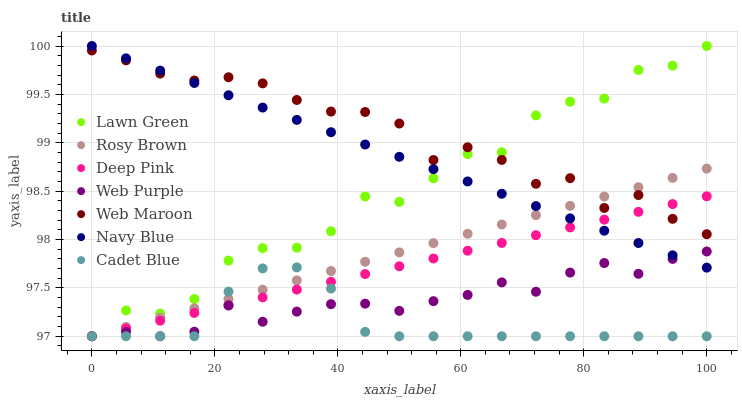Does Cadet Blue have the minimum area under the curve?
Answer yes or no. Yes. Does Web Maroon have the maximum area under the curve?
Answer yes or no. Yes. Does Deep Pink have the minimum area under the curve?
Answer yes or no. No. Does Deep Pink have the maximum area under the curve?
Answer yes or no. No. Is Rosy Brown the smoothest?
Answer yes or no. Yes. Is Lawn Green the roughest?
Answer yes or no. Yes. Is Deep Pink the smoothest?
Answer yes or no. No. Is Deep Pink the roughest?
Answer yes or no. No. Does Lawn Green have the lowest value?
Answer yes or no. Yes. Does Navy Blue have the lowest value?
Answer yes or no. No. Does Navy Blue have the highest value?
Answer yes or no. Yes. Does Deep Pink have the highest value?
Answer yes or no. No. Is Cadet Blue less than Navy Blue?
Answer yes or no. Yes. Is Navy Blue greater than Cadet Blue?
Answer yes or no. Yes. Does Web Purple intersect Rosy Brown?
Answer yes or no. Yes. Is Web Purple less than Rosy Brown?
Answer yes or no. No. Is Web Purple greater than Rosy Brown?
Answer yes or no. No. Does Cadet Blue intersect Navy Blue?
Answer yes or no. No. 